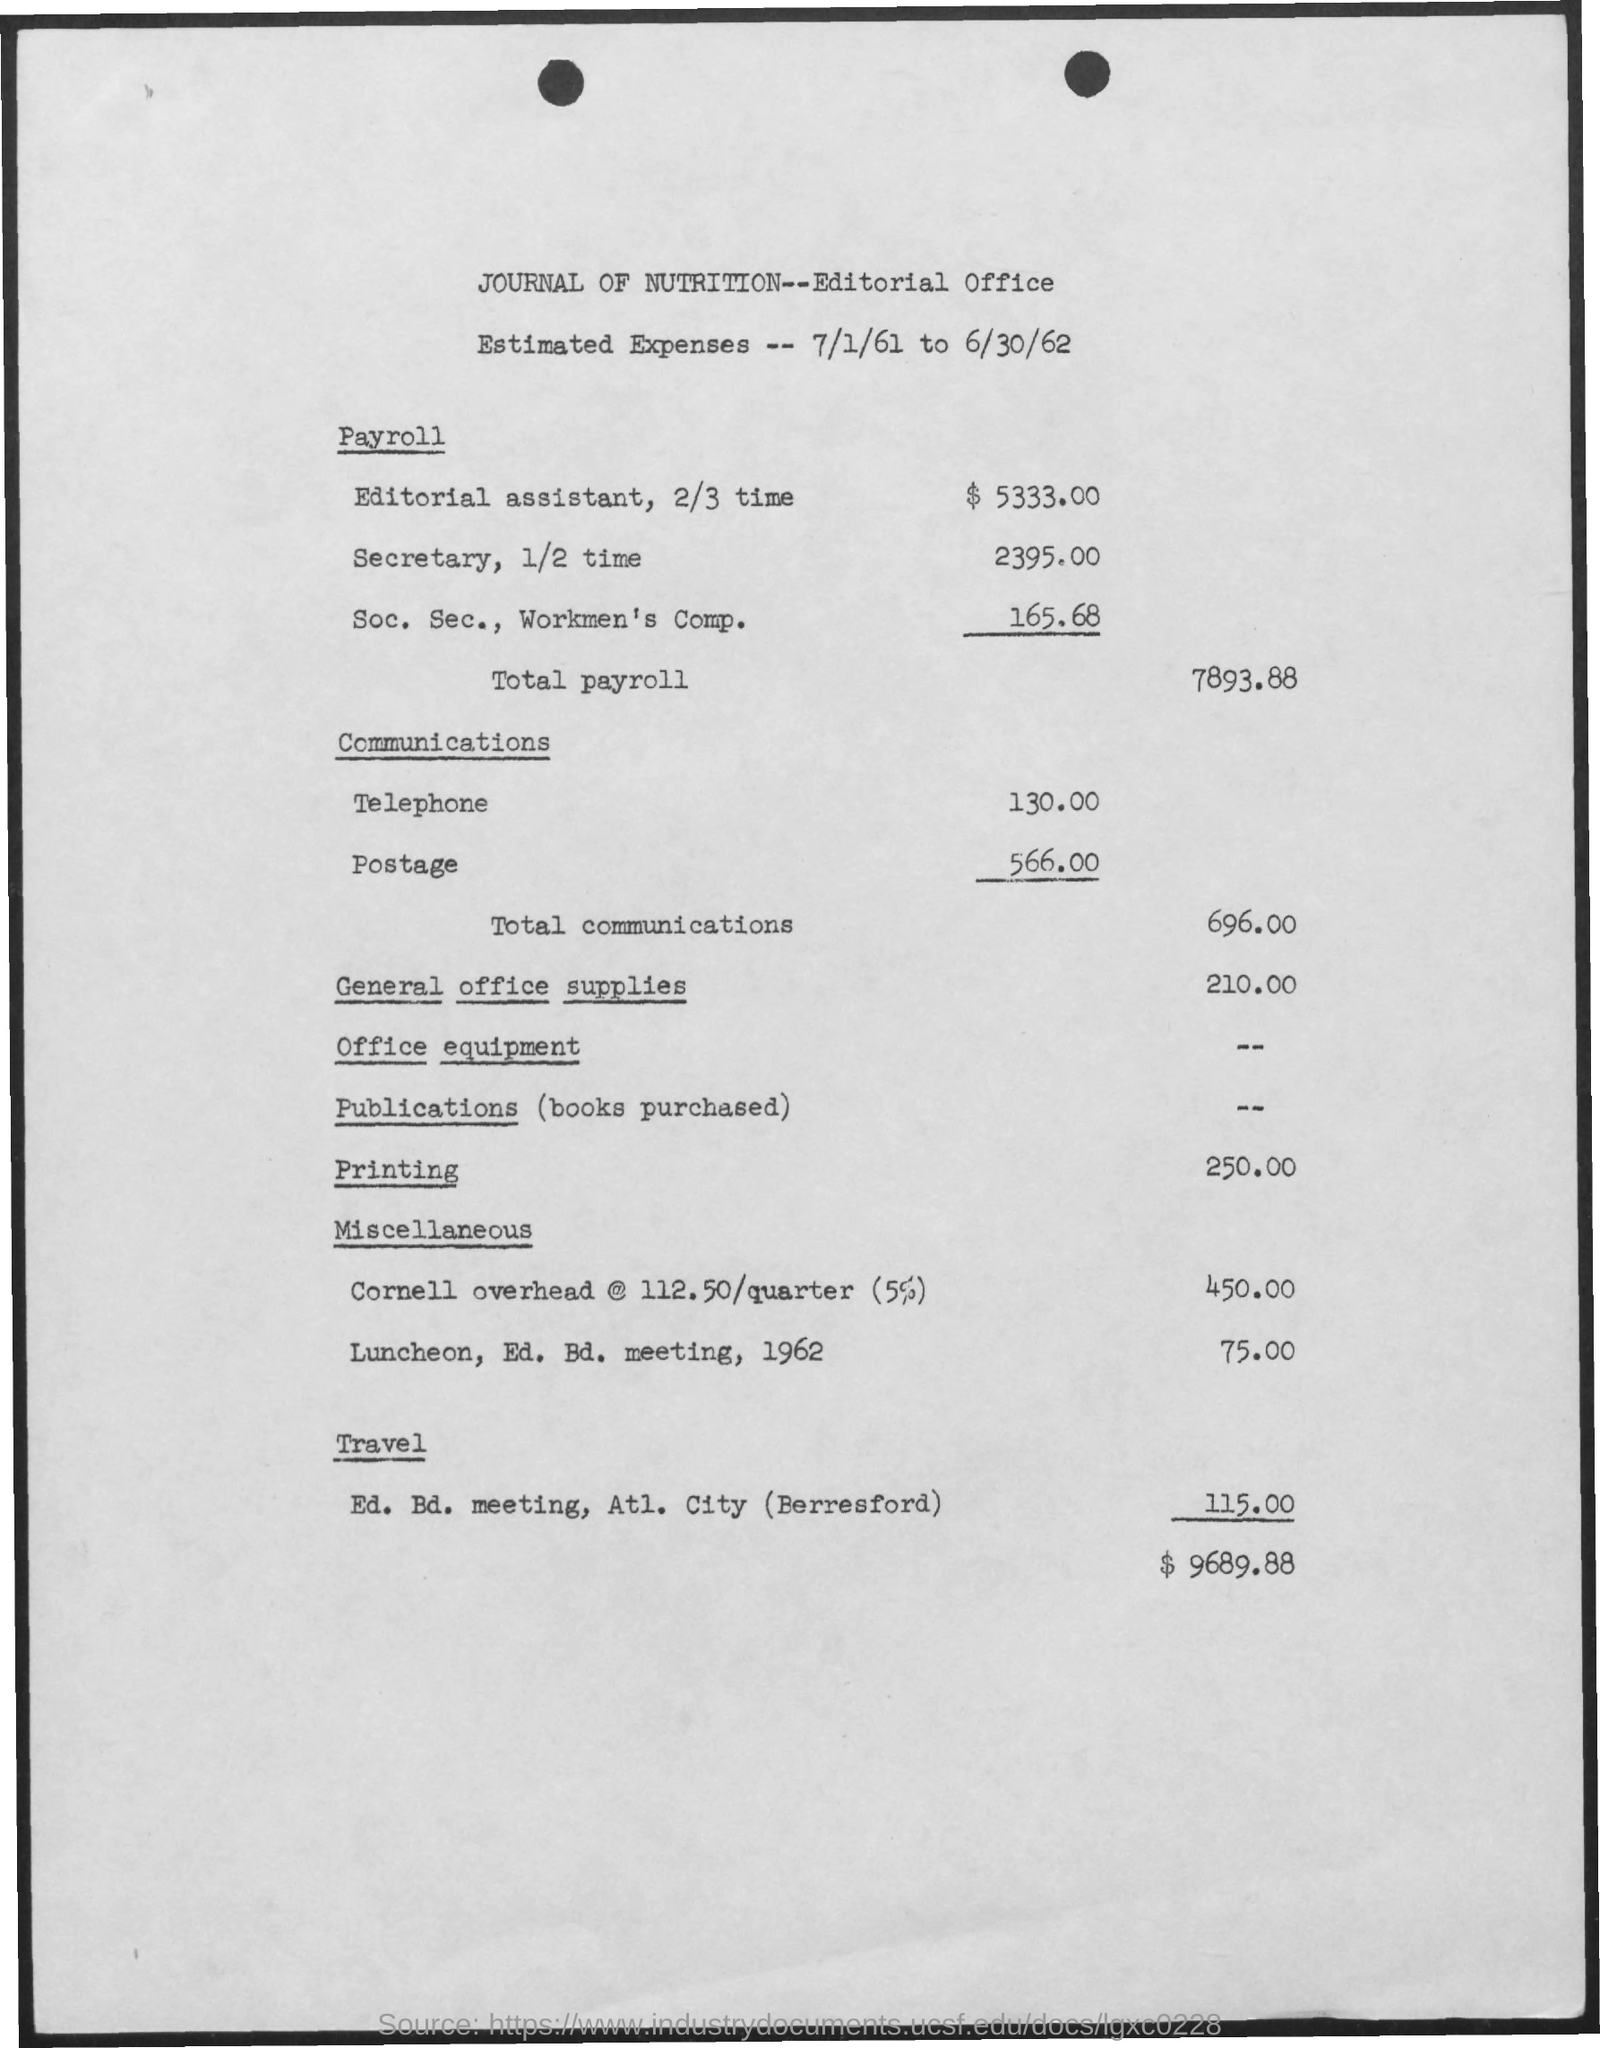What dates are the estimated expenses for?
Offer a very short reply. 7/1/61 to 6/30/62. What is the payroll for Editorial assistant, 2/3 time?
Your answer should be compact. 5333.00. What is the payroll for Secretary, 1/2 time?
Keep it short and to the point. 2395.00. What is the payroll for Soc. Sec.,Workmen's Comp.?
Ensure brevity in your answer.  165.68. What is the Total Payroll?
Provide a succinct answer. 7893.88. What is the amount for telephone?
Offer a very short reply. 130.00. What is the amount for Postage?
Your answer should be compact. 566.00. What is the amount for Printing?
Keep it short and to the point. 250.00. What is the amount for total communications?
Offer a terse response. 696.00. What is the amount for general office supplies?
Your response must be concise. 210.00. 